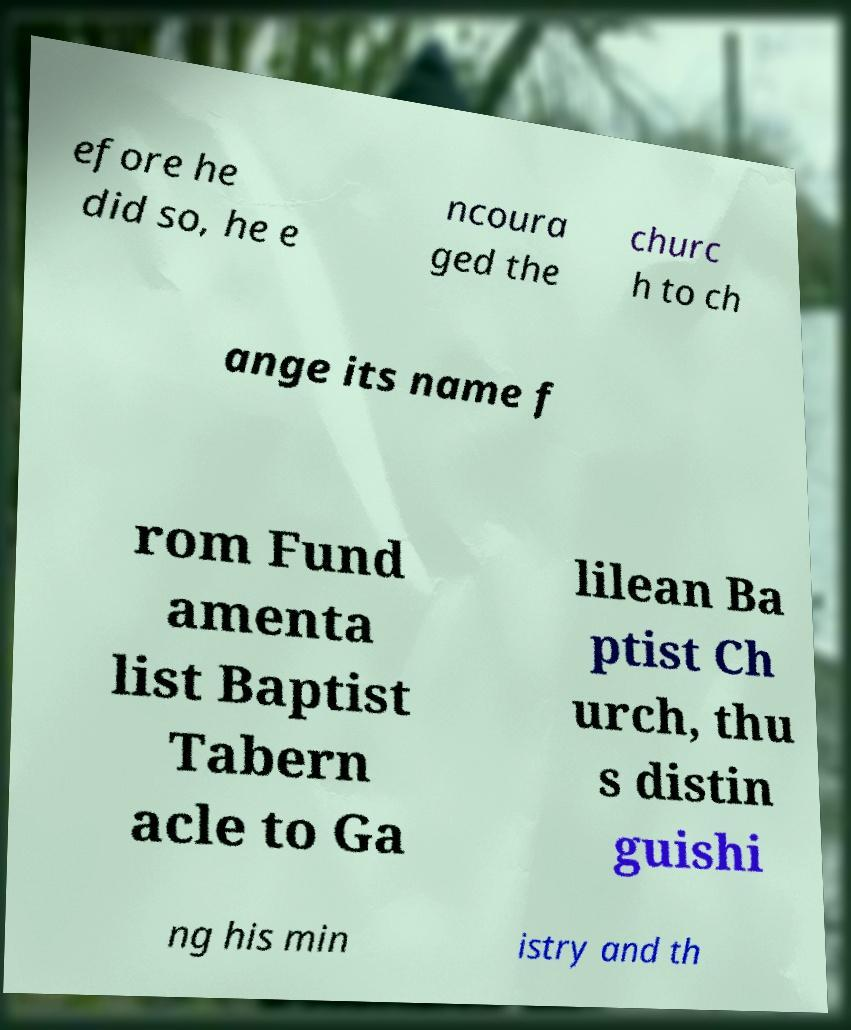Could you extract and type out the text from this image? efore he did so, he e ncoura ged the churc h to ch ange its name f rom Fund amenta list Baptist Tabern acle to Ga lilean Ba ptist Ch urch, thu s distin guishi ng his min istry and th 